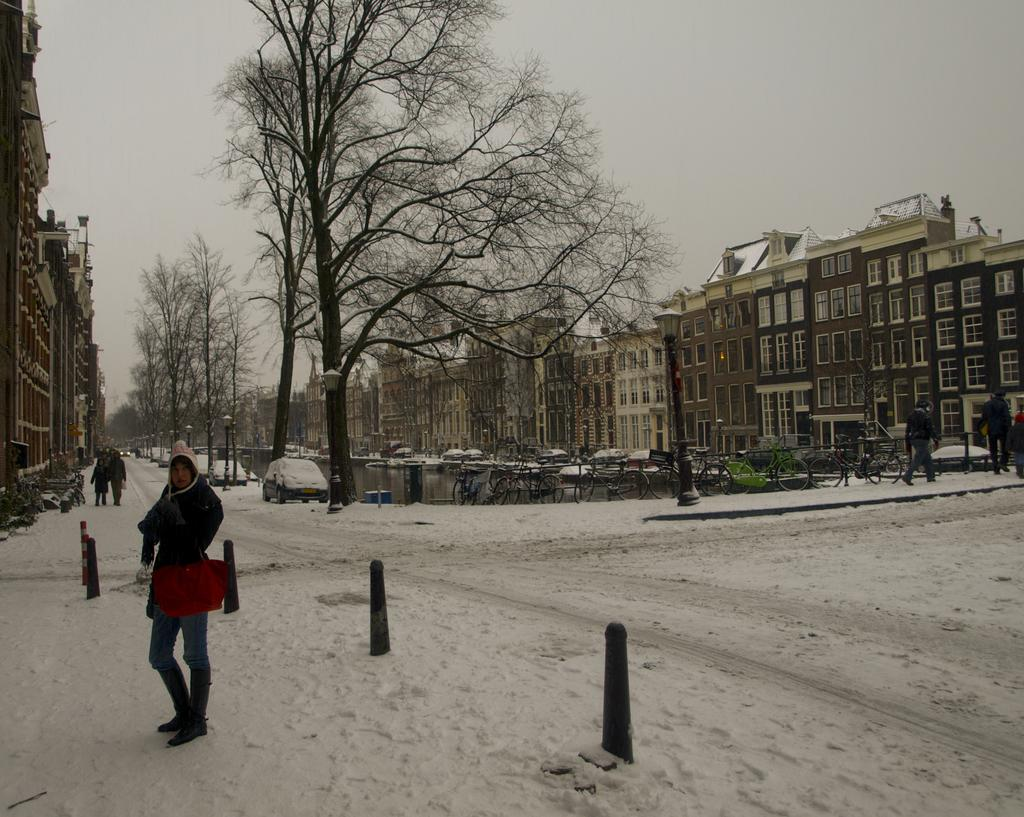What type of structures can be seen in the image? There are buildings in the image. What natural elements are present in the image? There are trees in the image. Can you describe the people in the image? There is a group of people in the image. What can be seen in the middle of the image? There are vehicles, water, bicycles, and poles in the middle of the image. What is the weather like in the image? There is snow visible in the image, indicating a cold or wintery setting. What type of humor can be seen in the image? There is no humor present in the image; it is a scene with buildings, trees, people, vehicles, water, bicycles, poles, and snow. What is the group of people using to carry their belongings in the image? There is no mention of a basket or any belongings being carried by the group of people in the image. 